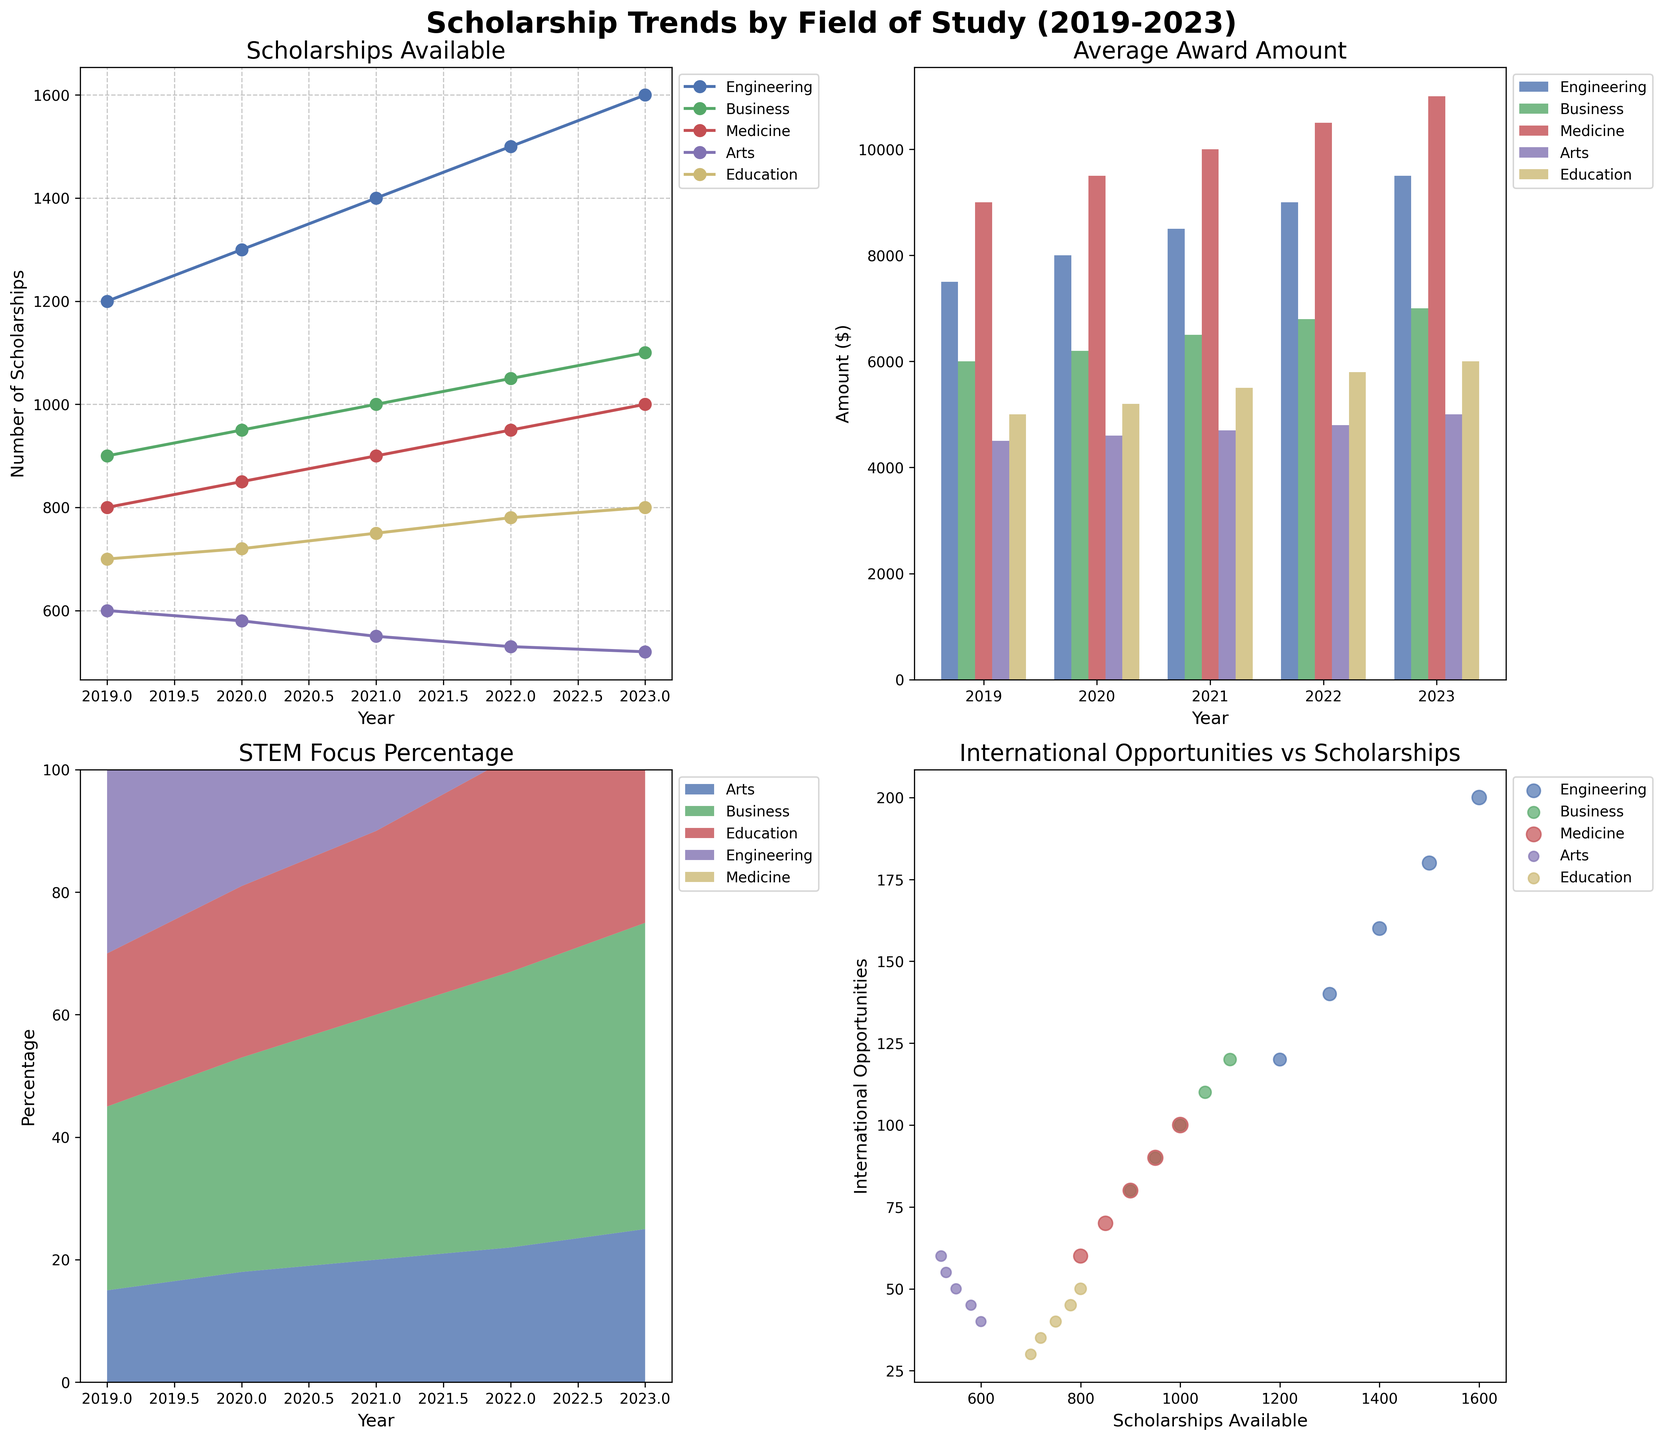What's the overall trend in the number of scholarships available for Engineering from 2019 to 2023? The line plot for scholarships available shows that the number of scholarships for Engineering is increasing each year from 1200 in 2019 to 1600 in 2023.
Answer: Increasing How does the average award amount for Medicine in 2023 compare to that in 2019? From the bar plot, the average award amount for Medicine increases from $9000 in 2019 to $11000 in 2023.
Answer: Increases Which field had the highest STEM focus percentage in 2021? According to the stacked area plot, Engineering had the highest STEM focus percentage in 2021 at 90%.
Answer: Engineering How many international opportunities were available for Arts scholarships in 2020? The scatter plot shows Arts with approximately 45 international opportunities in 2020.
Answer: 45 In which year did Business have the highest number of scholarships available? Referring to the line plot, Business had the highest number of scholarships available in 2023, totaling 1100 scholarships.
Answer: 2023 What is the average STEM focus percentage for Education from 2019 to 2023? Referring to the stacked area plot: (25+28+30+35+40) / 5 = 31.6.
Answer: 31.6 Which field shows the most constant average award amount from 2019 to 2023? From the bar plot, Arts had the most constant average award amount, varying only slightly around $4500 to $5000.
Answer: Arts Between 2019 and 2023, which field showed the largest increase in the average award amount? From the bar plot, Education increased its average award amount from $5000 in 2019 to $6000 in 2023 ($6000-$5000=$1000 increment).
Answer: Education Is there a correlation between the number of scholarships available and international opportunities for Engineering? From the scatter plot, as the number of Engineering scholarships increased from 1200 to 1600, international opportunities also increased from 120 to 200, indicating a positive correlation.
Answer: Positive correlation Which year had the least scholarships available across all fields combined? Summing the line plot data for all fields by year: 
2019: 1200+900+800+600+700=4200 
2020: 1300+950+850+580+720=4400 
2021: 1400+1000+900+550+750=4600 
2022: 1500+1050+950+530+780=4810 
2023: 1600+1100+1000+520+800=5020
2019 had the least scholarships available.
Answer: 2019 